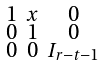Convert formula to latex. <formula><loc_0><loc_0><loc_500><loc_500>\begin{smallmatrix} 1 & x & 0 \\ 0 & 1 & 0 \\ 0 & 0 & I _ { r - t - 1 } \end{smallmatrix}</formula> 